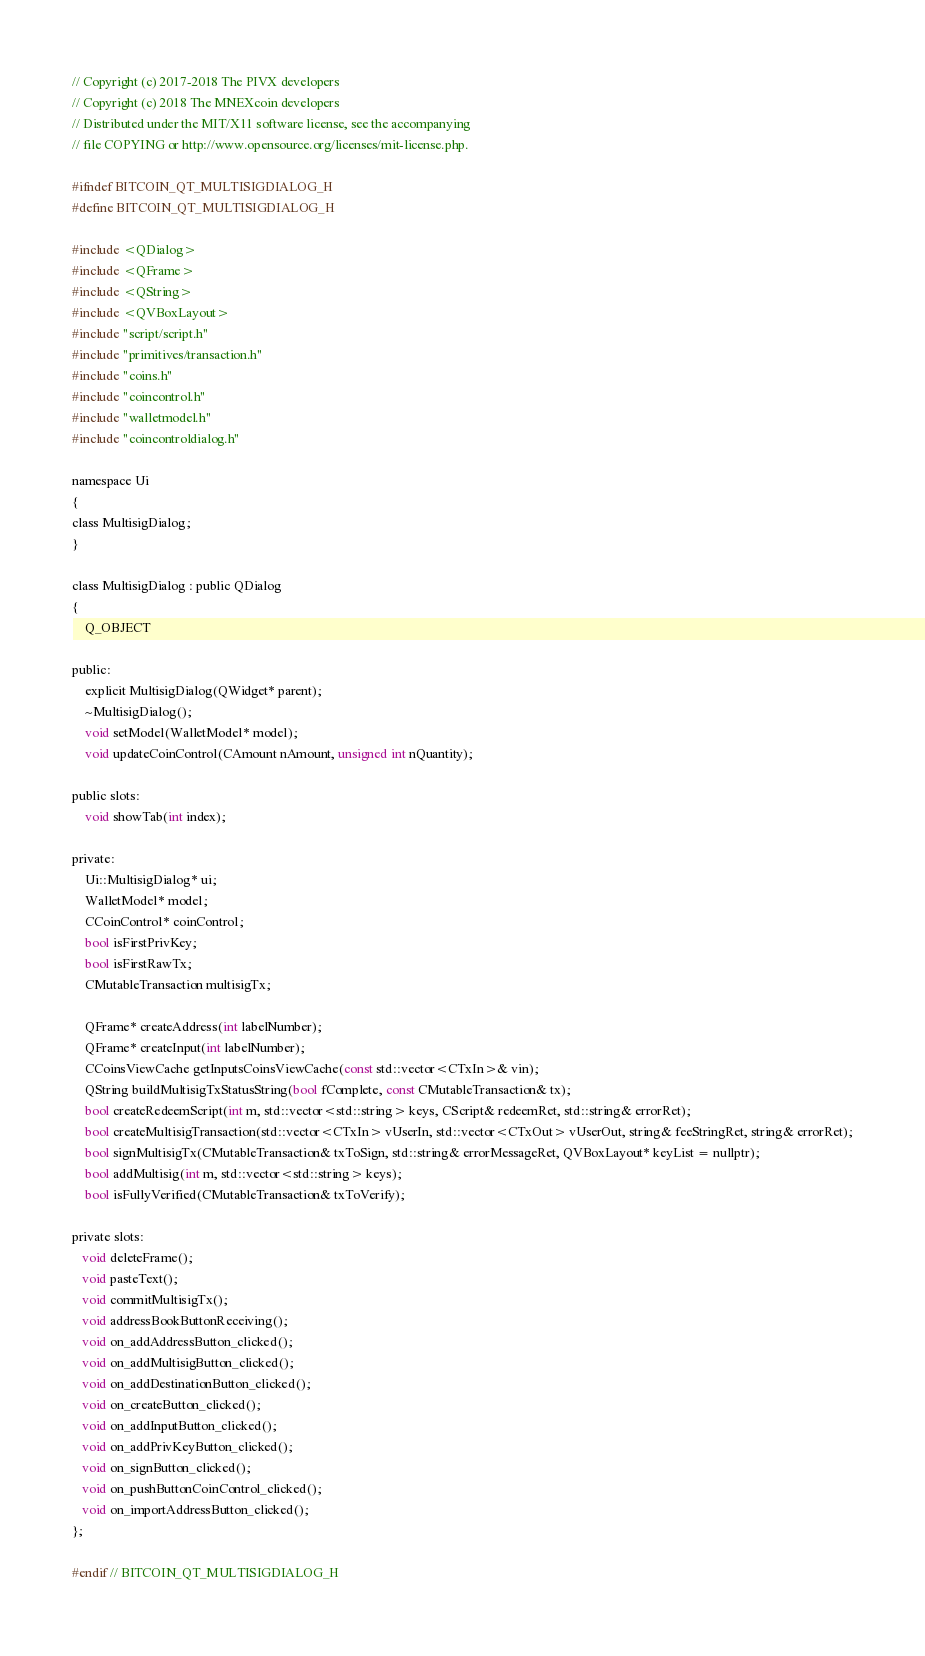<code> <loc_0><loc_0><loc_500><loc_500><_C_>// Copyright (c) 2017-2018 The PIVX developers
// Copyright (c) 2018 The MNEXcoin developers
// Distributed under the MIT/X11 software license, see the accompanying
// file COPYING or http://www.opensource.org/licenses/mit-license.php.

#ifndef BITCOIN_QT_MULTISIGDIALOG_H
#define BITCOIN_QT_MULTISIGDIALOG_H

#include <QDialog>
#include <QFrame>
#include <QString>
#include <QVBoxLayout>
#include "script/script.h"
#include "primitives/transaction.h"
#include "coins.h"
#include "coincontrol.h"
#include "walletmodel.h"
#include "coincontroldialog.h"

namespace Ui
{
class MultisigDialog;
}

class MultisigDialog : public QDialog
{
    Q_OBJECT

public:
    explicit MultisigDialog(QWidget* parent);
    ~MultisigDialog();
    void setModel(WalletModel* model);
    void updateCoinControl(CAmount nAmount, unsigned int nQuantity);

public slots:
    void showTab(int index);

private:
    Ui::MultisigDialog* ui;
    WalletModel* model;
    CCoinControl* coinControl;
    bool isFirstPrivKey;
    bool isFirstRawTx;
    CMutableTransaction multisigTx;

    QFrame* createAddress(int labelNumber);
    QFrame* createInput(int labelNumber);
    CCoinsViewCache getInputsCoinsViewCache(const std::vector<CTxIn>& vin);
    QString buildMultisigTxStatusString(bool fComplete, const CMutableTransaction& tx);
    bool createRedeemScript(int m, std::vector<std::string> keys, CScript& redeemRet, std::string& errorRet);
    bool createMultisigTransaction(std::vector<CTxIn> vUserIn, std::vector<CTxOut> vUserOut, string& feeStringRet, string& errorRet);
    bool signMultisigTx(CMutableTransaction& txToSign, std::string& errorMessageRet, QVBoxLayout* keyList = nullptr);
    bool addMultisig(int m, std::vector<std::string> keys);
    bool isFullyVerified(CMutableTransaction& txToVerify);

private slots:
   void deleteFrame();
   void pasteText();
   void commitMultisigTx();
   void addressBookButtonReceiving();
   void on_addAddressButton_clicked();
   void on_addMultisigButton_clicked();
   void on_addDestinationButton_clicked();
   void on_createButton_clicked();
   void on_addInputButton_clicked();
   void on_addPrivKeyButton_clicked();
   void on_signButton_clicked();
   void on_pushButtonCoinControl_clicked();
   void on_importAddressButton_clicked();
};

#endif // BITCOIN_QT_MULTISIGDIALOG_H
</code> 